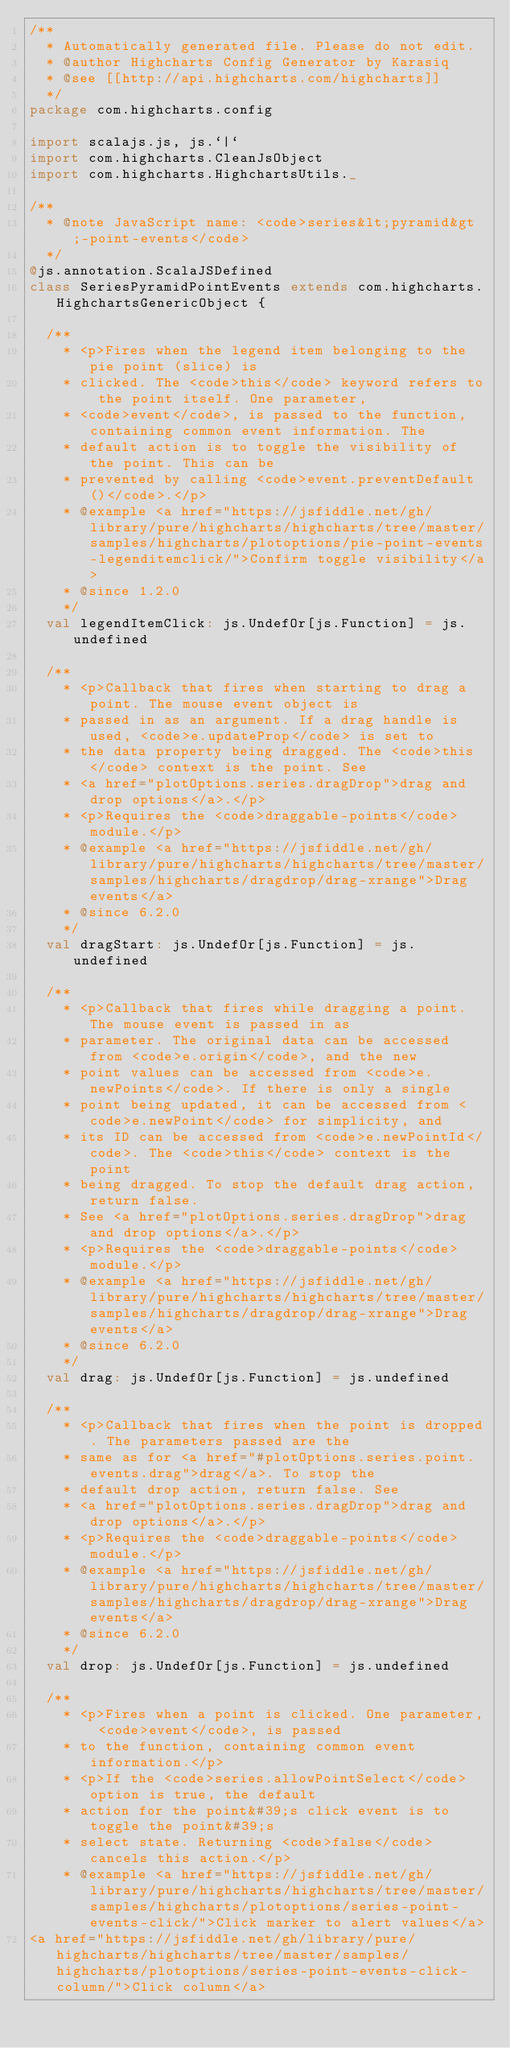Convert code to text. <code><loc_0><loc_0><loc_500><loc_500><_Scala_>/**
  * Automatically generated file. Please do not edit.
  * @author Highcharts Config Generator by Karasiq
  * @see [[http://api.highcharts.com/highcharts]]
  */
package com.highcharts.config

import scalajs.js, js.`|`
import com.highcharts.CleanJsObject
import com.highcharts.HighchartsUtils._

/**
  * @note JavaScript name: <code>series&lt;pyramid&gt;-point-events</code>
  */
@js.annotation.ScalaJSDefined
class SeriesPyramidPointEvents extends com.highcharts.HighchartsGenericObject {

  /**
    * <p>Fires when the legend item belonging to the pie point (slice) is
    * clicked. The <code>this</code> keyword refers to the point itself. One parameter,
    * <code>event</code>, is passed to the function, containing common event information. The
    * default action is to toggle the visibility of the point. This can be
    * prevented by calling <code>event.preventDefault()</code>.</p>
    * @example <a href="https://jsfiddle.net/gh/library/pure/highcharts/highcharts/tree/master/samples/highcharts/plotoptions/pie-point-events-legenditemclick/">Confirm toggle visibility</a>
    * @since 1.2.0
    */
  val legendItemClick: js.UndefOr[js.Function] = js.undefined

  /**
    * <p>Callback that fires when starting to drag a point. The mouse event object is
    * passed in as an argument. If a drag handle is used, <code>e.updateProp</code> is set to
    * the data property being dragged. The <code>this</code> context is the point. See
    * <a href="plotOptions.series.dragDrop">drag and drop options</a>.</p>
    * <p>Requires the <code>draggable-points</code> module.</p>
    * @example <a href="https://jsfiddle.net/gh/library/pure/highcharts/highcharts/tree/master/samples/highcharts/dragdrop/drag-xrange">Drag events</a>
    * @since 6.2.0
    */
  val dragStart: js.UndefOr[js.Function] = js.undefined

  /**
    * <p>Callback that fires while dragging a point. The mouse event is passed in as
    * parameter. The original data can be accessed from <code>e.origin</code>, and the new
    * point values can be accessed from <code>e.newPoints</code>. If there is only a single
    * point being updated, it can be accessed from <code>e.newPoint</code> for simplicity, and
    * its ID can be accessed from <code>e.newPointId</code>. The <code>this</code> context is the point
    * being dragged. To stop the default drag action, return false.
    * See <a href="plotOptions.series.dragDrop">drag and drop options</a>.</p>
    * <p>Requires the <code>draggable-points</code> module.</p>
    * @example <a href="https://jsfiddle.net/gh/library/pure/highcharts/highcharts/tree/master/samples/highcharts/dragdrop/drag-xrange">Drag events</a>
    * @since 6.2.0
    */
  val drag: js.UndefOr[js.Function] = js.undefined

  /**
    * <p>Callback that fires when the point is dropped. The parameters passed are the
    * same as for <a href="#plotOptions.series.point.events.drag">drag</a>. To stop the
    * default drop action, return false. See
    * <a href="plotOptions.series.dragDrop">drag and drop options</a>.</p>
    * <p>Requires the <code>draggable-points</code> module.</p>
    * @example <a href="https://jsfiddle.net/gh/library/pure/highcharts/highcharts/tree/master/samples/highcharts/dragdrop/drag-xrange">Drag events</a>
    * @since 6.2.0
    */
  val drop: js.UndefOr[js.Function] = js.undefined

  /**
    * <p>Fires when a point is clicked. One parameter, <code>event</code>, is passed
    * to the function, containing common event information.</p>
    * <p>If the <code>series.allowPointSelect</code> option is true, the default
    * action for the point&#39;s click event is to toggle the point&#39;s
    * select state. Returning <code>false</code> cancels this action.</p>
    * @example <a href="https://jsfiddle.net/gh/library/pure/highcharts/highcharts/tree/master/samples/highcharts/plotoptions/series-point-events-click/">Click marker to alert values</a>
<a href="https://jsfiddle.net/gh/library/pure/highcharts/highcharts/tree/master/samples/highcharts/plotoptions/series-point-events-click-column/">Click column</a></code> 